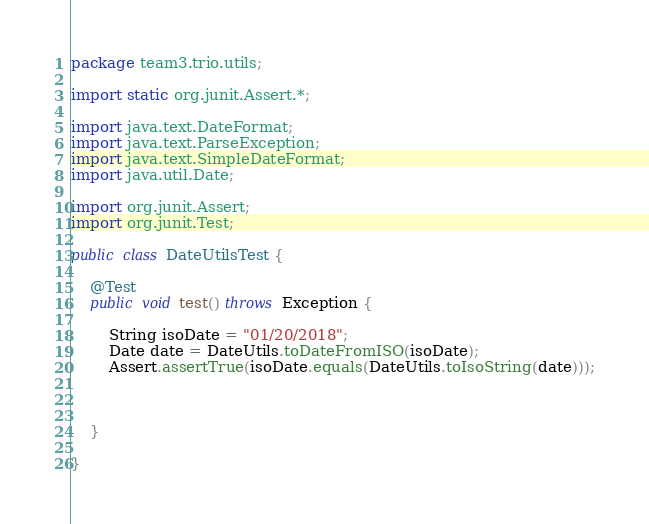Convert code to text. <code><loc_0><loc_0><loc_500><loc_500><_Java_>package team3.trio.utils;

import static org.junit.Assert.*;

import java.text.DateFormat;
import java.text.ParseException;
import java.text.SimpleDateFormat;
import java.util.Date;

import org.junit.Assert;
import org.junit.Test;

public class DateUtilsTest {

	@Test
	public void test() throws Exception {
		
		String isoDate = "01/20/2018";
		Date date = DateUtils.toDateFromISO(isoDate);
		Assert.assertTrue(isoDate.equals(DateUtils.toIsoString(date)));

		
		
	}

}
</code> 